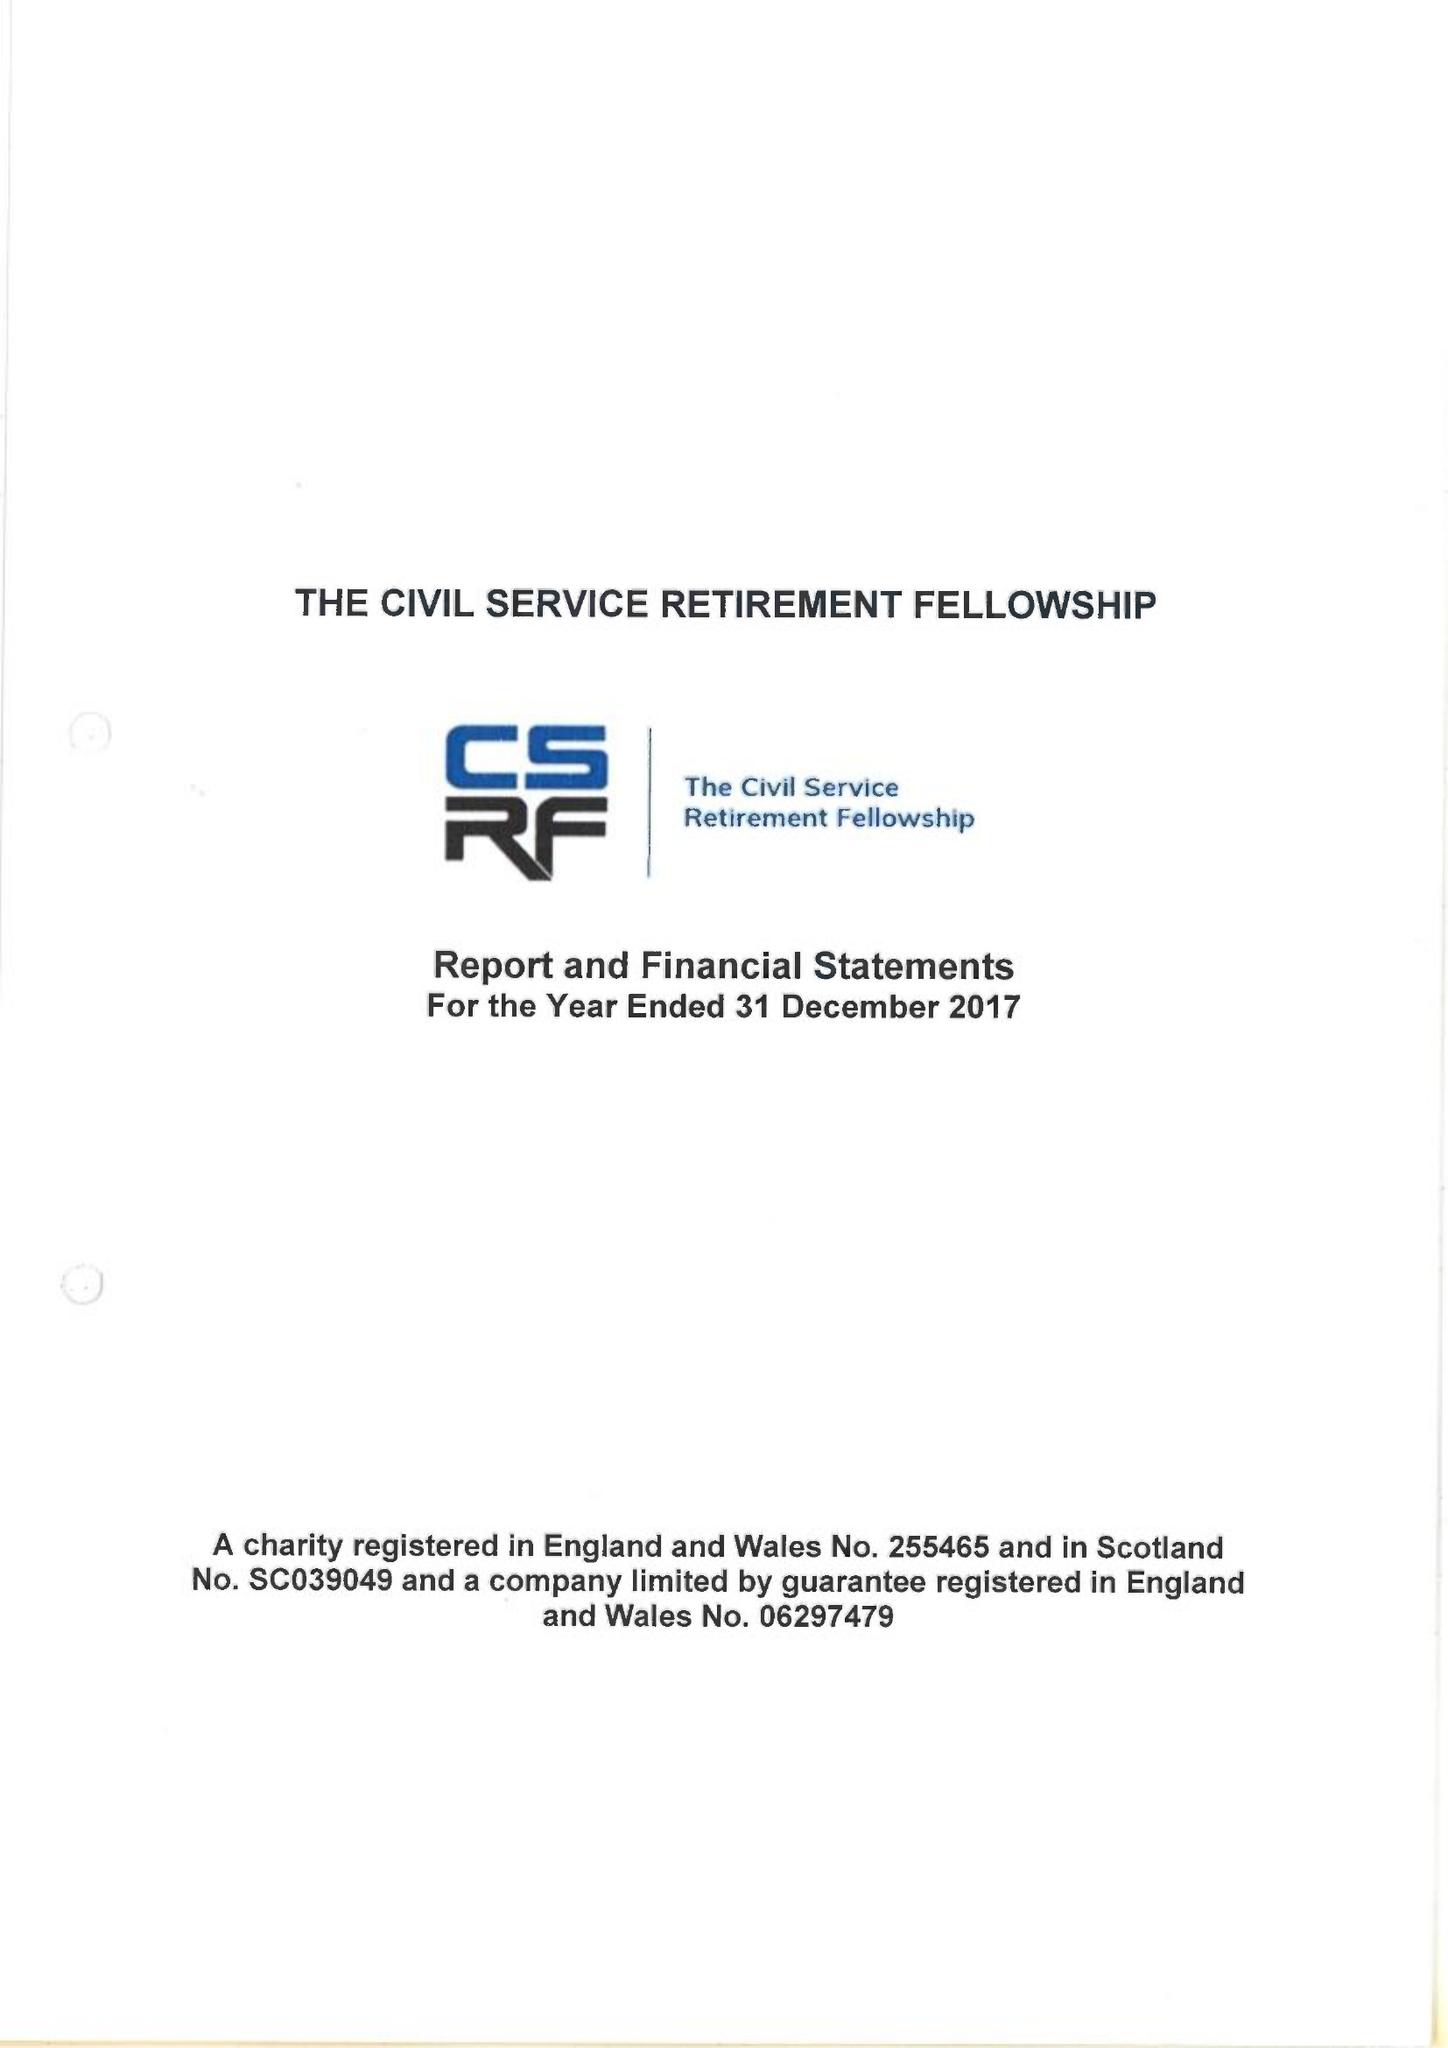What is the value for the charity_number?
Answer the question using a single word or phrase. 255465 